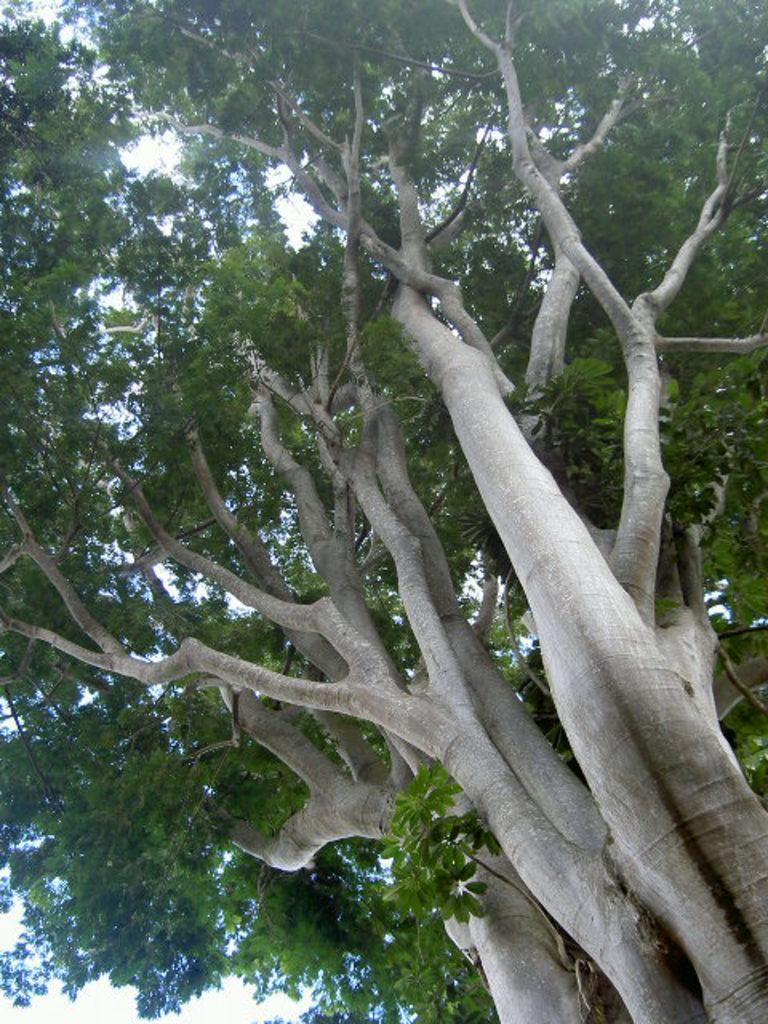Can you describe this image briefly? In this image I can see few trees. 